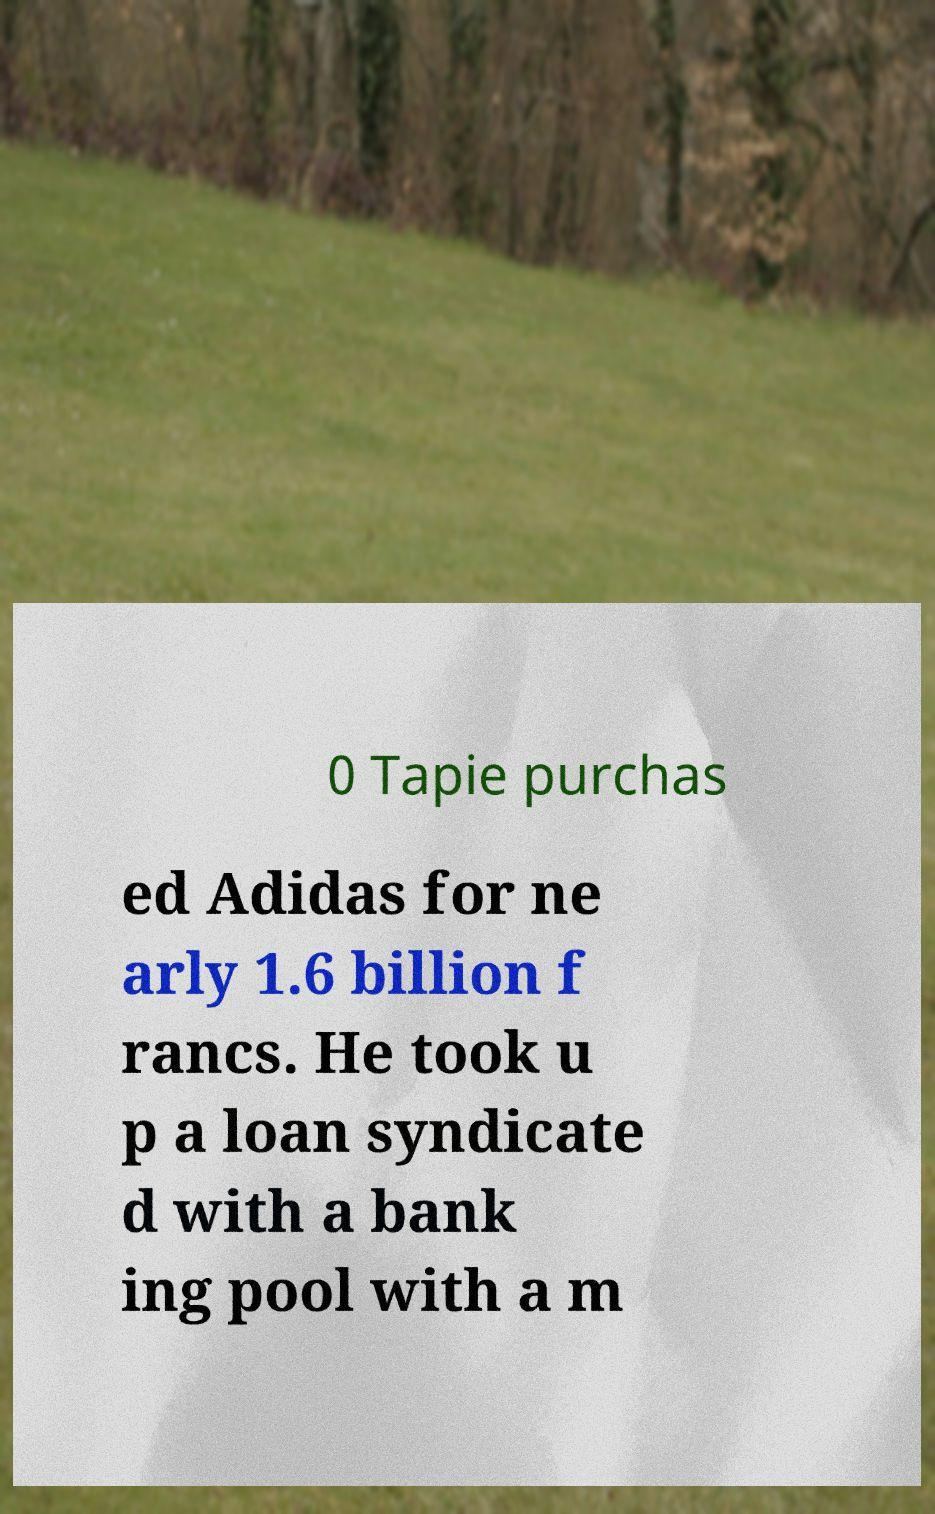Can you read and provide the text displayed in the image?This photo seems to have some interesting text. Can you extract and type it out for me? 0 Tapie purchas ed Adidas for ne arly 1.6 billion f rancs. He took u p a loan syndicate d with a bank ing pool with a m 